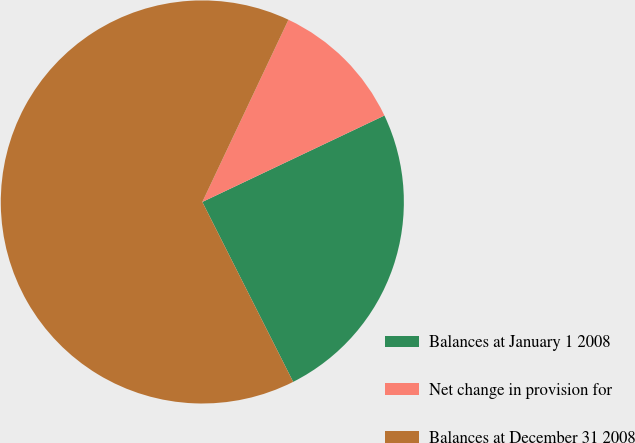<chart> <loc_0><loc_0><loc_500><loc_500><pie_chart><fcel>Balances at January 1 2008<fcel>Net change in provision for<fcel>Balances at December 31 2008<nl><fcel>24.61%<fcel>10.92%<fcel>64.47%<nl></chart> 